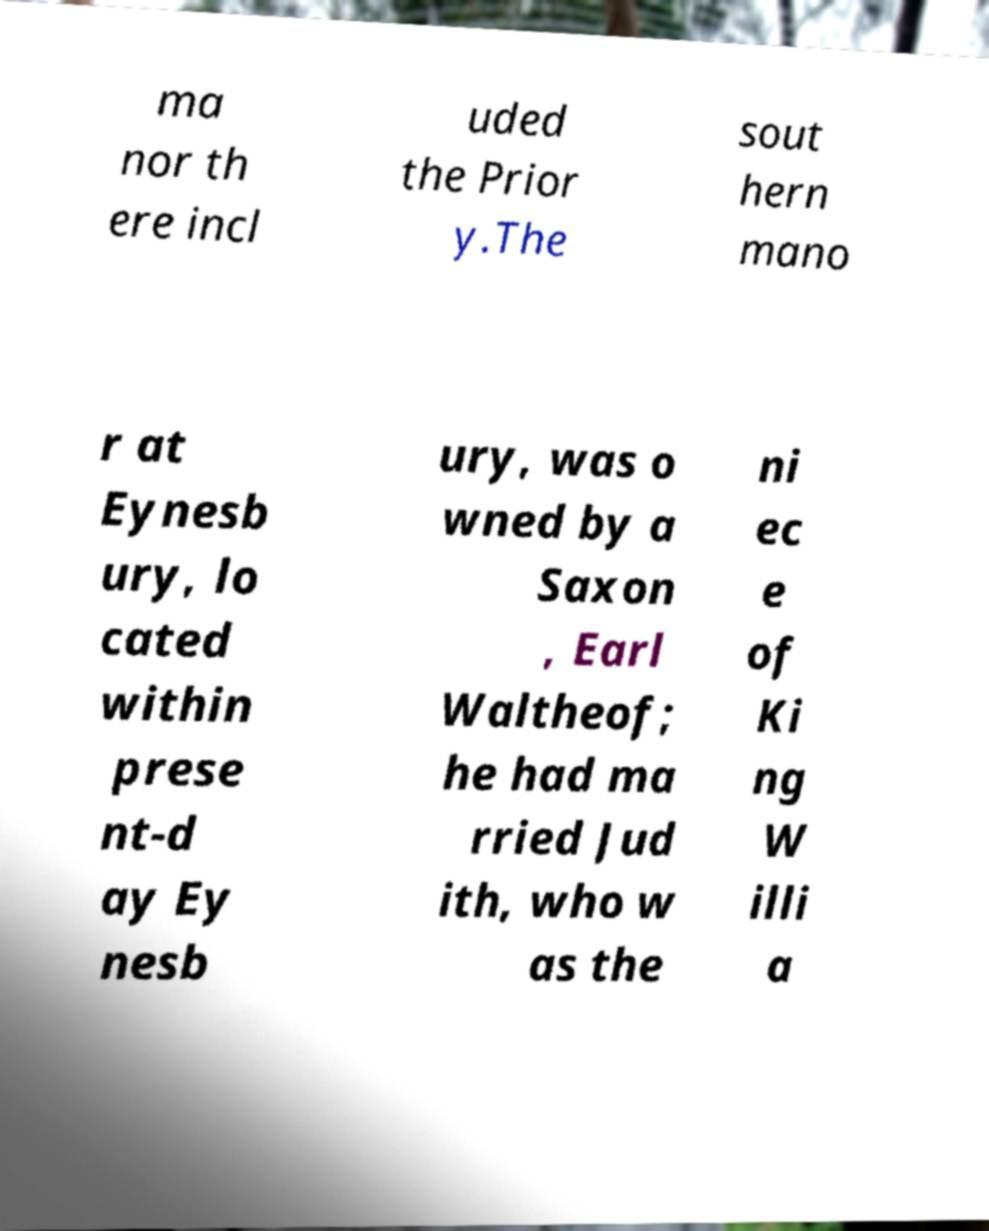Please read and relay the text visible in this image. What does it say? ma nor th ere incl uded the Prior y.The sout hern mano r at Eynesb ury, lo cated within prese nt-d ay Ey nesb ury, was o wned by a Saxon , Earl Waltheof; he had ma rried Jud ith, who w as the ni ec e of Ki ng W illi a 